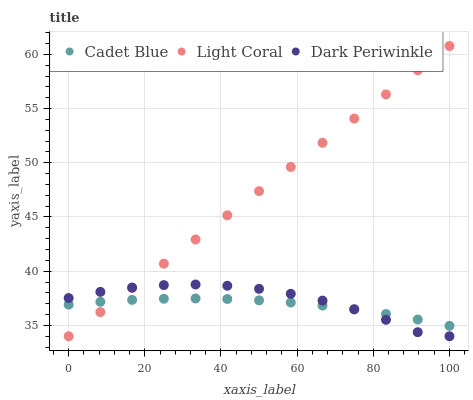Does Cadet Blue have the minimum area under the curve?
Answer yes or no. Yes. Does Light Coral have the maximum area under the curve?
Answer yes or no. Yes. Does Dark Periwinkle have the minimum area under the curve?
Answer yes or no. No. Does Dark Periwinkle have the maximum area under the curve?
Answer yes or no. No. Is Light Coral the smoothest?
Answer yes or no. Yes. Is Dark Periwinkle the roughest?
Answer yes or no. Yes. Is Cadet Blue the smoothest?
Answer yes or no. No. Is Cadet Blue the roughest?
Answer yes or no. No. Does Light Coral have the lowest value?
Answer yes or no. Yes. Does Cadet Blue have the lowest value?
Answer yes or no. No. Does Light Coral have the highest value?
Answer yes or no. Yes. Does Dark Periwinkle have the highest value?
Answer yes or no. No. Does Dark Periwinkle intersect Cadet Blue?
Answer yes or no. Yes. Is Dark Periwinkle less than Cadet Blue?
Answer yes or no. No. Is Dark Periwinkle greater than Cadet Blue?
Answer yes or no. No. 